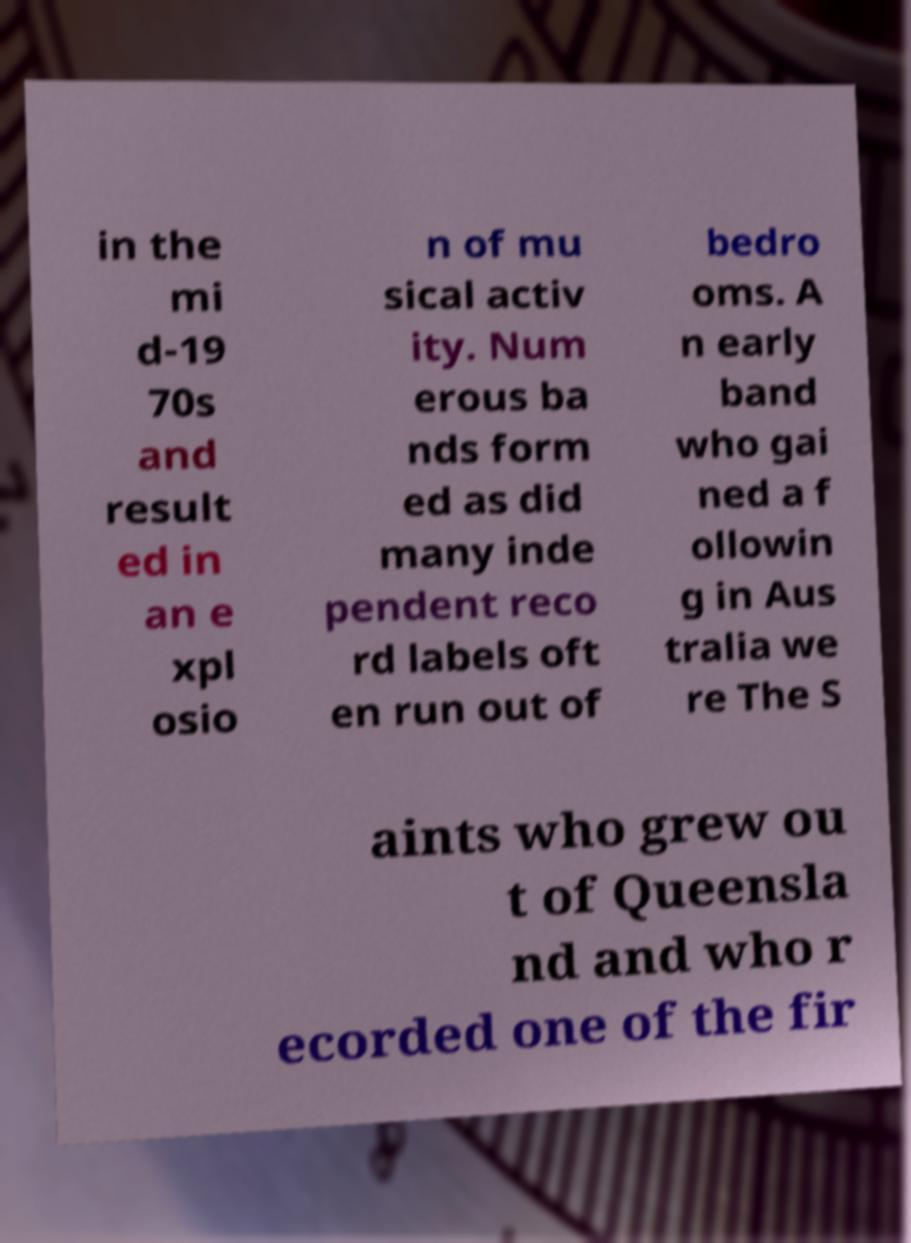Can you accurately transcribe the text from the provided image for me? in the mi d-19 70s and result ed in an e xpl osio n of mu sical activ ity. Num erous ba nds form ed as did many inde pendent reco rd labels oft en run out of bedro oms. A n early band who gai ned a f ollowin g in Aus tralia we re The S aints who grew ou t of Queensla nd and who r ecorded one of the fir 